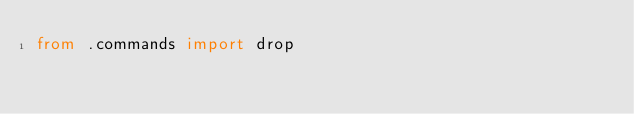<code> <loc_0><loc_0><loc_500><loc_500><_Python_>from .commands import drop
</code> 